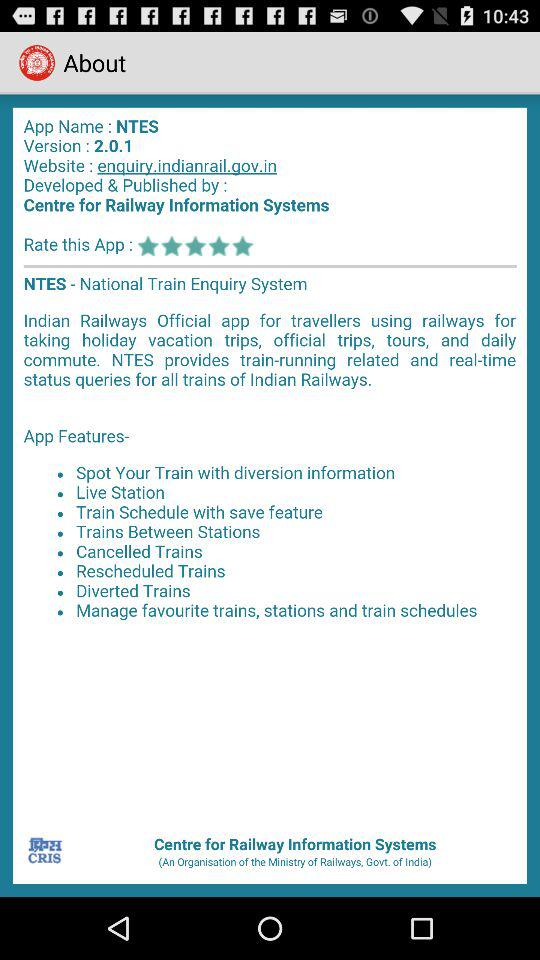What's the app name? The app name is "NTES". 